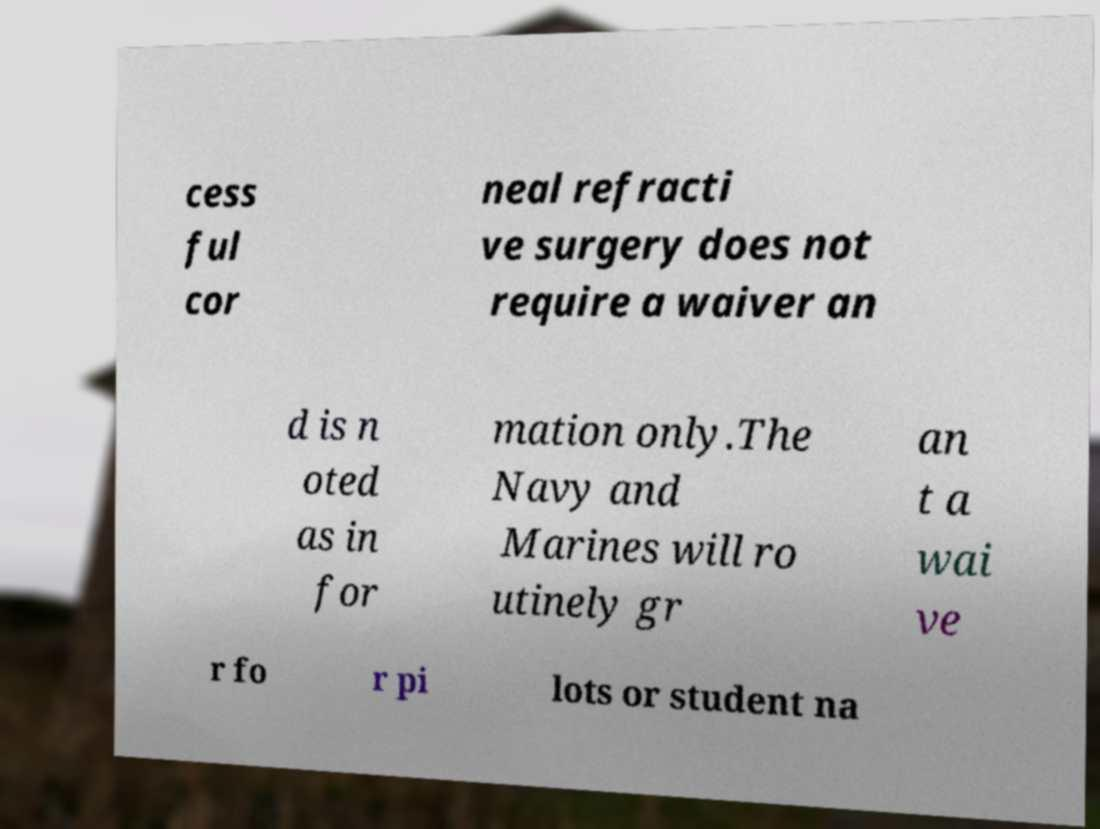Please read and relay the text visible in this image. What does it say? cess ful cor neal refracti ve surgery does not require a waiver an d is n oted as in for mation only.The Navy and Marines will ro utinely gr an t a wai ve r fo r pi lots or student na 